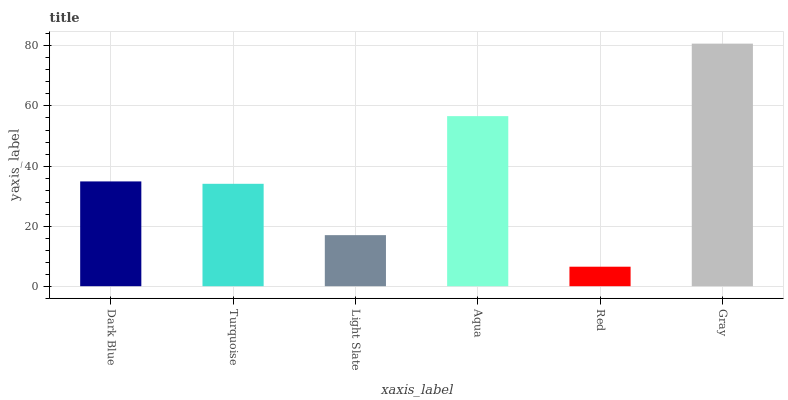Is Red the minimum?
Answer yes or no. Yes. Is Gray the maximum?
Answer yes or no. Yes. Is Turquoise the minimum?
Answer yes or no. No. Is Turquoise the maximum?
Answer yes or no. No. Is Dark Blue greater than Turquoise?
Answer yes or no. Yes. Is Turquoise less than Dark Blue?
Answer yes or no. Yes. Is Turquoise greater than Dark Blue?
Answer yes or no. No. Is Dark Blue less than Turquoise?
Answer yes or no. No. Is Dark Blue the high median?
Answer yes or no. Yes. Is Turquoise the low median?
Answer yes or no. Yes. Is Light Slate the high median?
Answer yes or no. No. Is Red the low median?
Answer yes or no. No. 